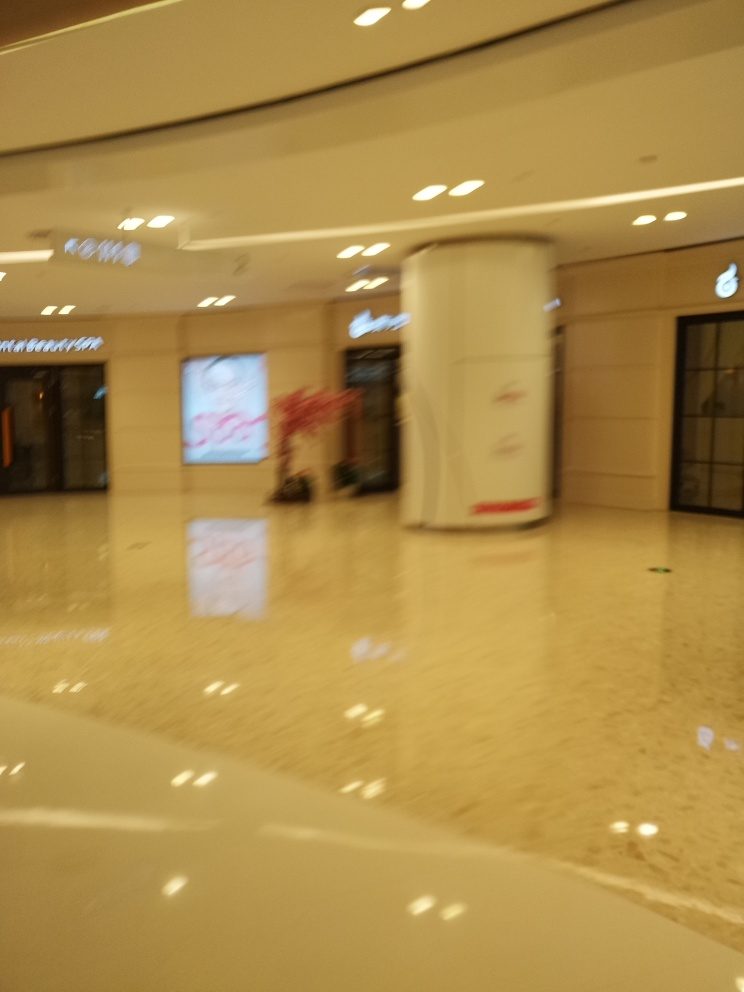What could be the cause of the blurriness in this photo? The blurriness could be due to several factors such as camera shake, incorrect focus settings, or a slow shutter speed combined with movement either by the subject or the photographer. 